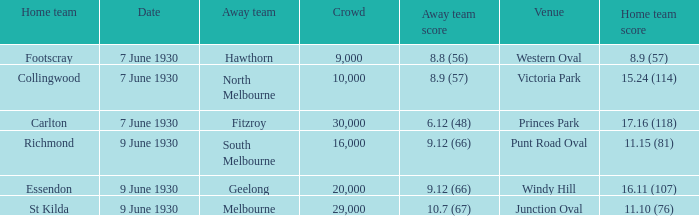What is the mean attendance for hawthorn games when they are the away team? 9000.0. 